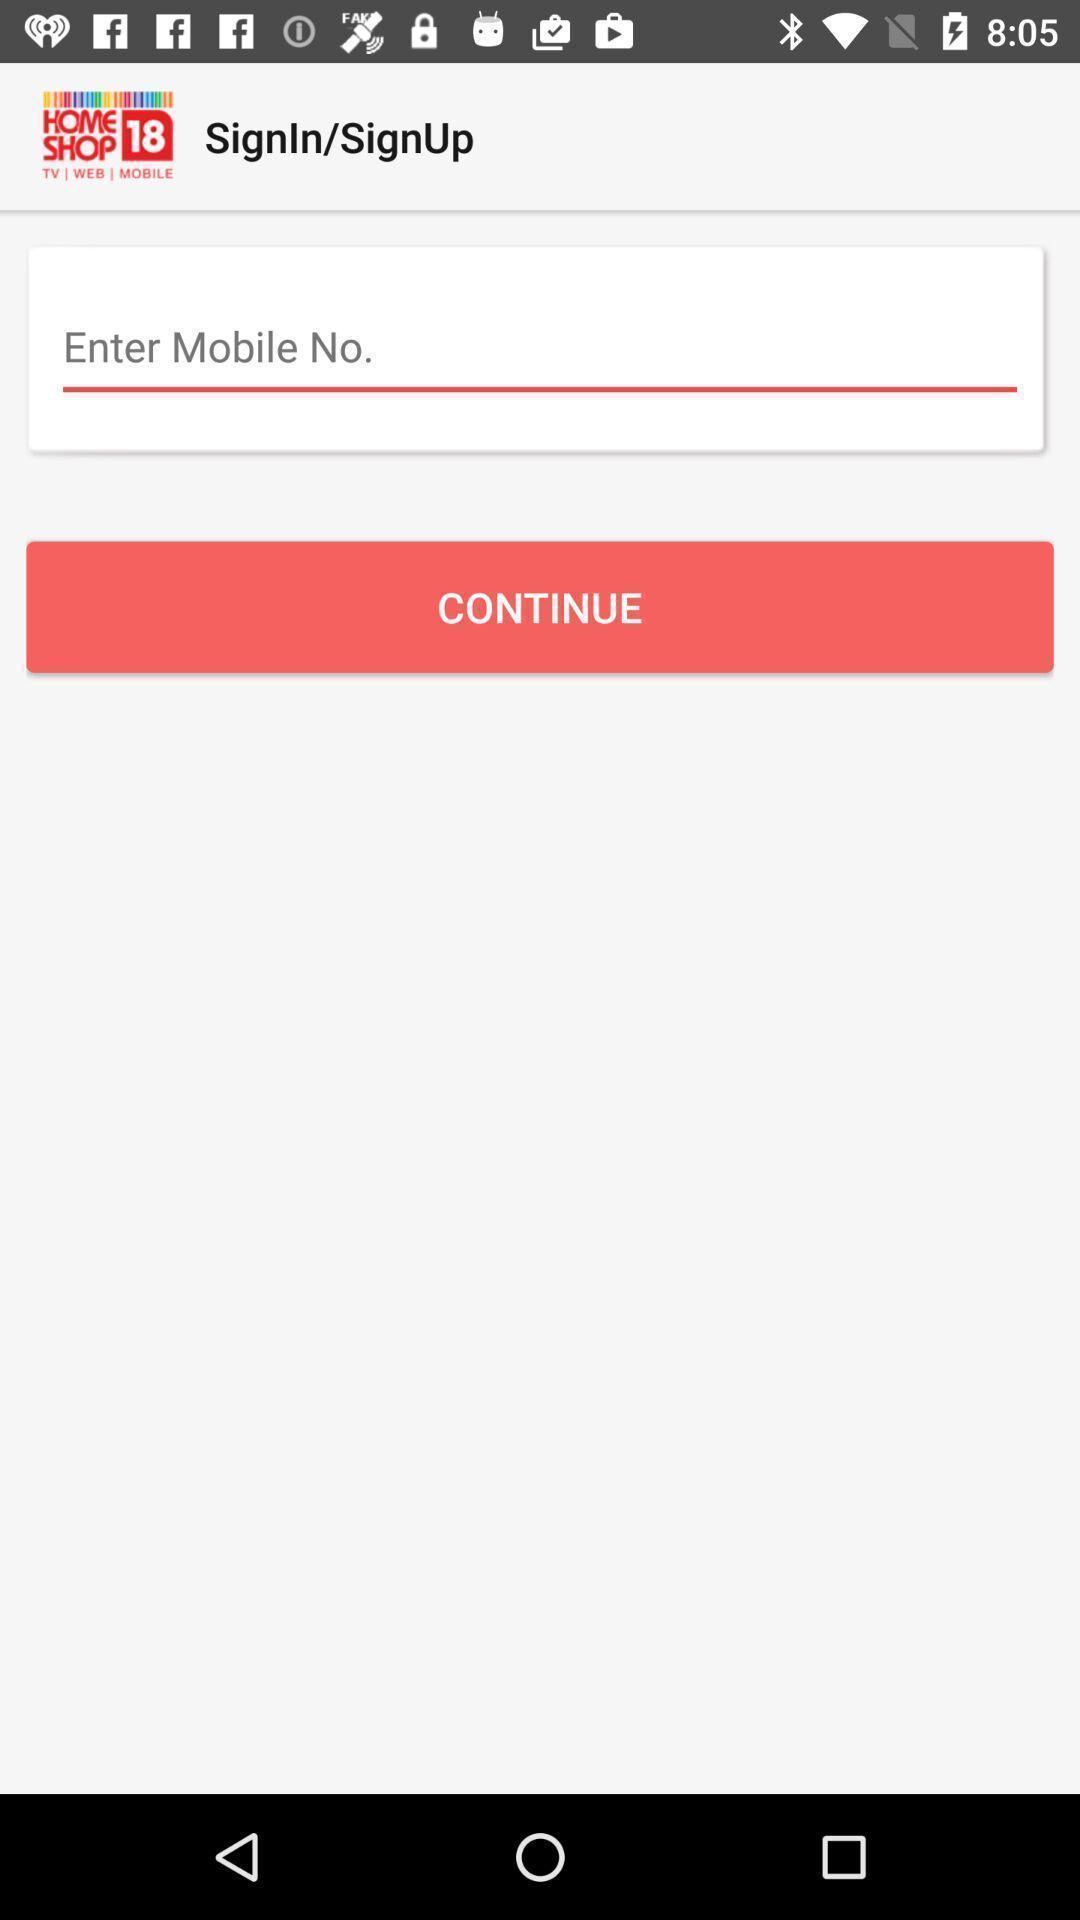Summarize the information in this screenshot. Sign-in page of an online shopping app. 